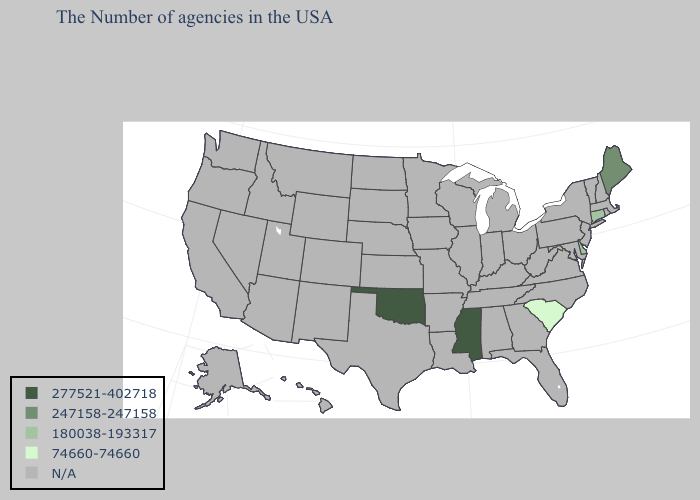What is the value of Arkansas?
Quick response, please. N/A. Name the states that have a value in the range 247158-247158?
Write a very short answer. Maine. Does the first symbol in the legend represent the smallest category?
Write a very short answer. No. Does the map have missing data?
Short answer required. Yes. Does the map have missing data?
Write a very short answer. Yes. What is the lowest value in the Northeast?
Keep it brief. 180038-193317. How many symbols are there in the legend?
Keep it brief. 5. Does the map have missing data?
Short answer required. Yes. Which states have the highest value in the USA?
Be succinct. Mississippi, Oklahoma. Name the states that have a value in the range N/A?
Write a very short answer. Massachusetts, Rhode Island, New Hampshire, Vermont, New York, New Jersey, Maryland, Pennsylvania, Virginia, North Carolina, West Virginia, Ohio, Florida, Georgia, Michigan, Kentucky, Indiana, Alabama, Tennessee, Wisconsin, Illinois, Louisiana, Missouri, Arkansas, Minnesota, Iowa, Kansas, Nebraska, Texas, South Dakota, North Dakota, Wyoming, Colorado, New Mexico, Utah, Montana, Arizona, Idaho, Nevada, California, Washington, Oregon, Alaska, Hawaii. How many symbols are there in the legend?
Quick response, please. 5. What is the highest value in the South ?
Give a very brief answer. 277521-402718. Does South Carolina have the lowest value in the USA?
Answer briefly. Yes. 